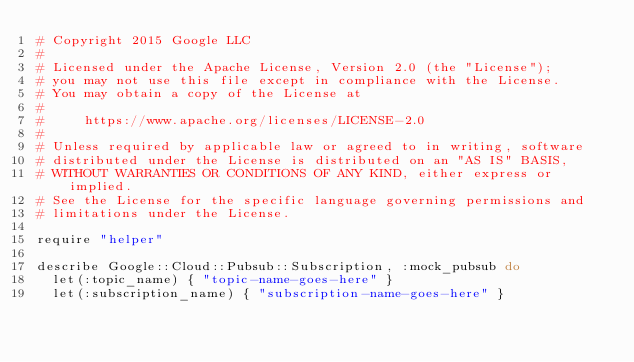Convert code to text. <code><loc_0><loc_0><loc_500><loc_500><_Ruby_># Copyright 2015 Google LLC
#
# Licensed under the Apache License, Version 2.0 (the "License");
# you may not use this file except in compliance with the License.
# You may obtain a copy of the License at
#
#     https://www.apache.org/licenses/LICENSE-2.0
#
# Unless required by applicable law or agreed to in writing, software
# distributed under the License is distributed on an "AS IS" BASIS,
# WITHOUT WARRANTIES OR CONDITIONS OF ANY KIND, either express or implied.
# See the License for the specific language governing permissions and
# limitations under the License.

require "helper"

describe Google::Cloud::Pubsub::Subscription, :mock_pubsub do
  let(:topic_name) { "topic-name-goes-here" }
  let(:subscription_name) { "subscription-name-goes-here" }</code> 